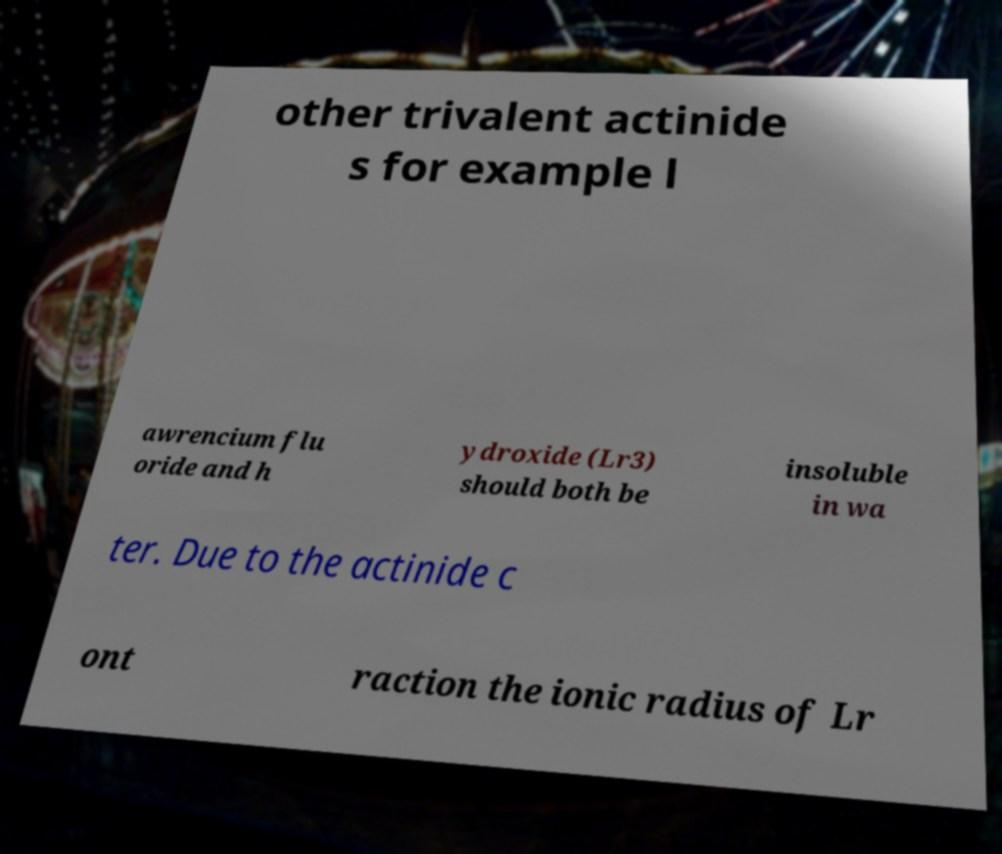Could you assist in decoding the text presented in this image and type it out clearly? other trivalent actinide s for example l awrencium flu oride and h ydroxide (Lr3) should both be insoluble in wa ter. Due to the actinide c ont raction the ionic radius of Lr 